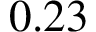<formula> <loc_0><loc_0><loc_500><loc_500>0 . 2 3</formula> 